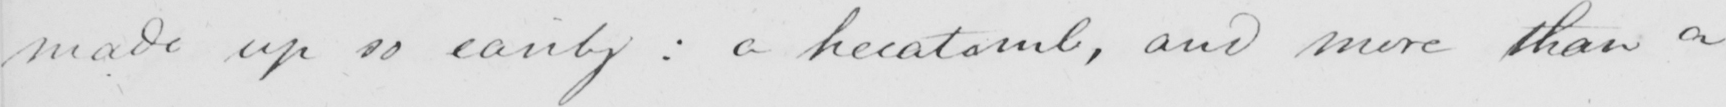Please provide the text content of this handwritten line. made up so easily :  a hecatomb , and more than a 